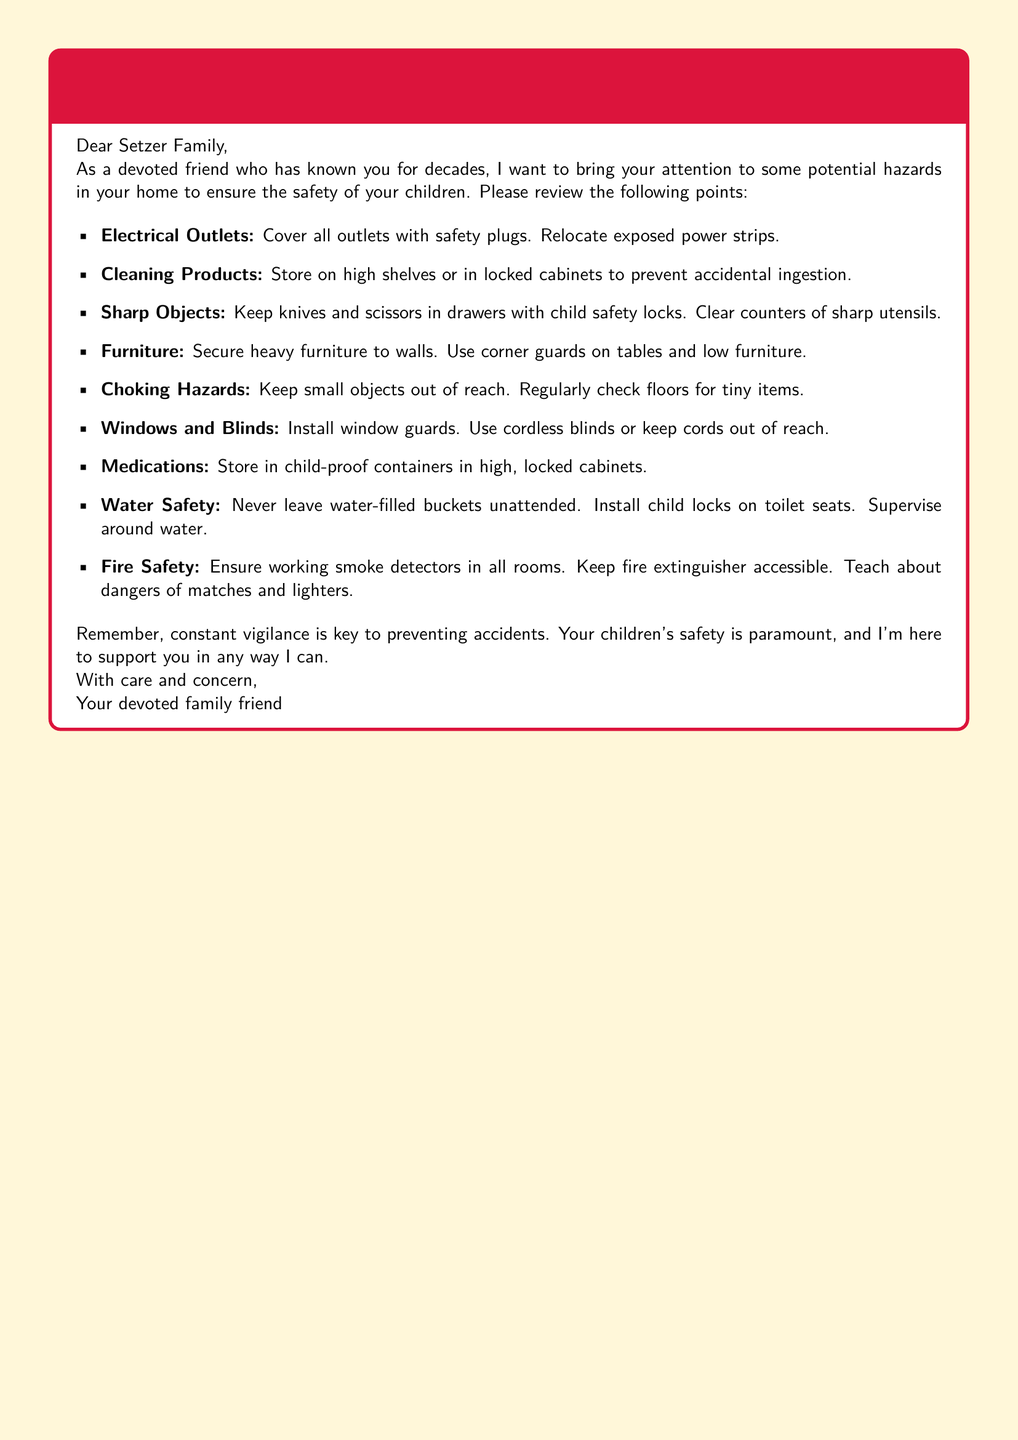What is the title of the document? The title of the document is clearly stated at the top of the warning label.
Answer: Child Safety Reminder: Potential Hazards in the Setzer Household What color is used for the warning label's box frame? The color used for the box frame is specified in the document.
Answer: Red How many items are listed under the safety reminders? The number of items is the count of bullet points provided in the document.
Answer: Eight What should be done with sharp objects according to the reminders? The document explicitly states the action to be taken regarding sharp objects.
Answer: Keep in drawers with child safety locks Where should cleaning products be stored? The document specifies the recommended storage location for cleaning products to ensure safety.
Answer: High shelves or in locked cabinets What type of guards should be installed on windows? The document indicates a specific safety measure concerning windows.
Answer: Window guards What is mentioned as a water safety precaution? The document contains specific instructions regarding water safety among children.
Answer: Never leave water-filled buckets unattended How many types of safety measures relate to fire? The document mentions specific safety measures regarding fire safety.
Answer: Three 